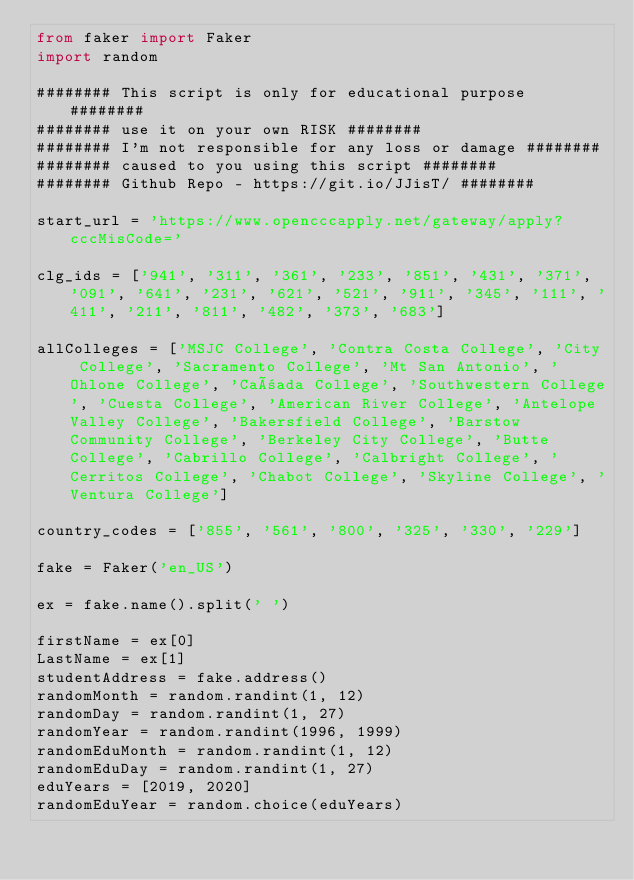Convert code to text. <code><loc_0><loc_0><loc_500><loc_500><_Python_>from faker import Faker
import random

######## This script is only for educational purpose ########
######## use it on your own RISK ########
######## I'm not responsible for any loss or damage ########
######## caused to you using this script ########
######## Github Repo - https://git.io/JJisT/ ########

start_url = 'https://www.opencccapply.net/gateway/apply?cccMisCode='

clg_ids = ['941', '311', '361', '233', '851', '431', '371', '091', '641', '231', '621', '521', '911', '345', '111', '411', '211', '811', '482', '373', '683']

allColleges = ['MSJC College', 'Contra Costa College', 'City College', 'Sacramento College', 'Mt San Antonio', 'Ohlone College', 'Cañada College', 'Southwestern College', 'Cuesta College', 'American River College', 'Antelope Valley College', 'Bakersfield College', 'Barstow Community College', 'Berkeley City College', 'Butte College', 'Cabrillo College', 'Calbright College', 'Cerritos College', 'Chabot College', 'Skyline College', 'Ventura College']

country_codes = ['855', '561', '800', '325', '330', '229']

fake = Faker('en_US')

ex = fake.name().split(' ')

firstName = ex[0]
LastName = ex[1]
studentAddress = fake.address()
randomMonth = random.randint(1, 12)
randomDay = random.randint(1, 27)
randomYear = random.randint(1996, 1999)
randomEduMonth = random.randint(1, 12)
randomEduDay = random.randint(1, 27)
eduYears = [2019, 2020]
randomEduYear = random.choice(eduYears)
</code> 